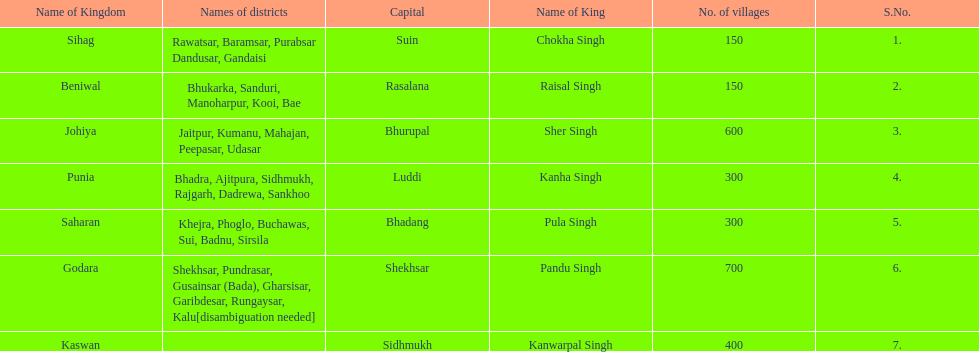What is the next kingdom listed after sihag? Beniwal. 